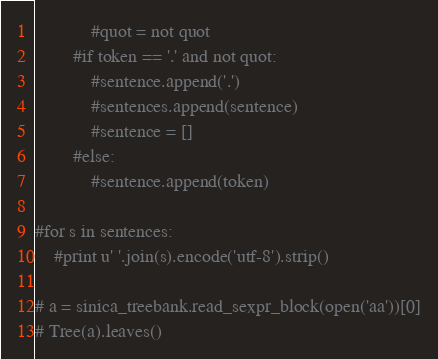Convert code to text. <code><loc_0><loc_0><loc_500><loc_500><_Python_>            #quot = not quot
        #if token == '.' and not quot:
            #sentence.append('.')
            #sentences.append(sentence)
            #sentence = []
        #else:
            #sentence.append(token)

#for s in sentences:
    #print u' '.join(s).encode('utf-8').strip()

# a = sinica_treebank.read_sexpr_block(open('aa'))[0]
# Tree(a).leaves() 
</code> 